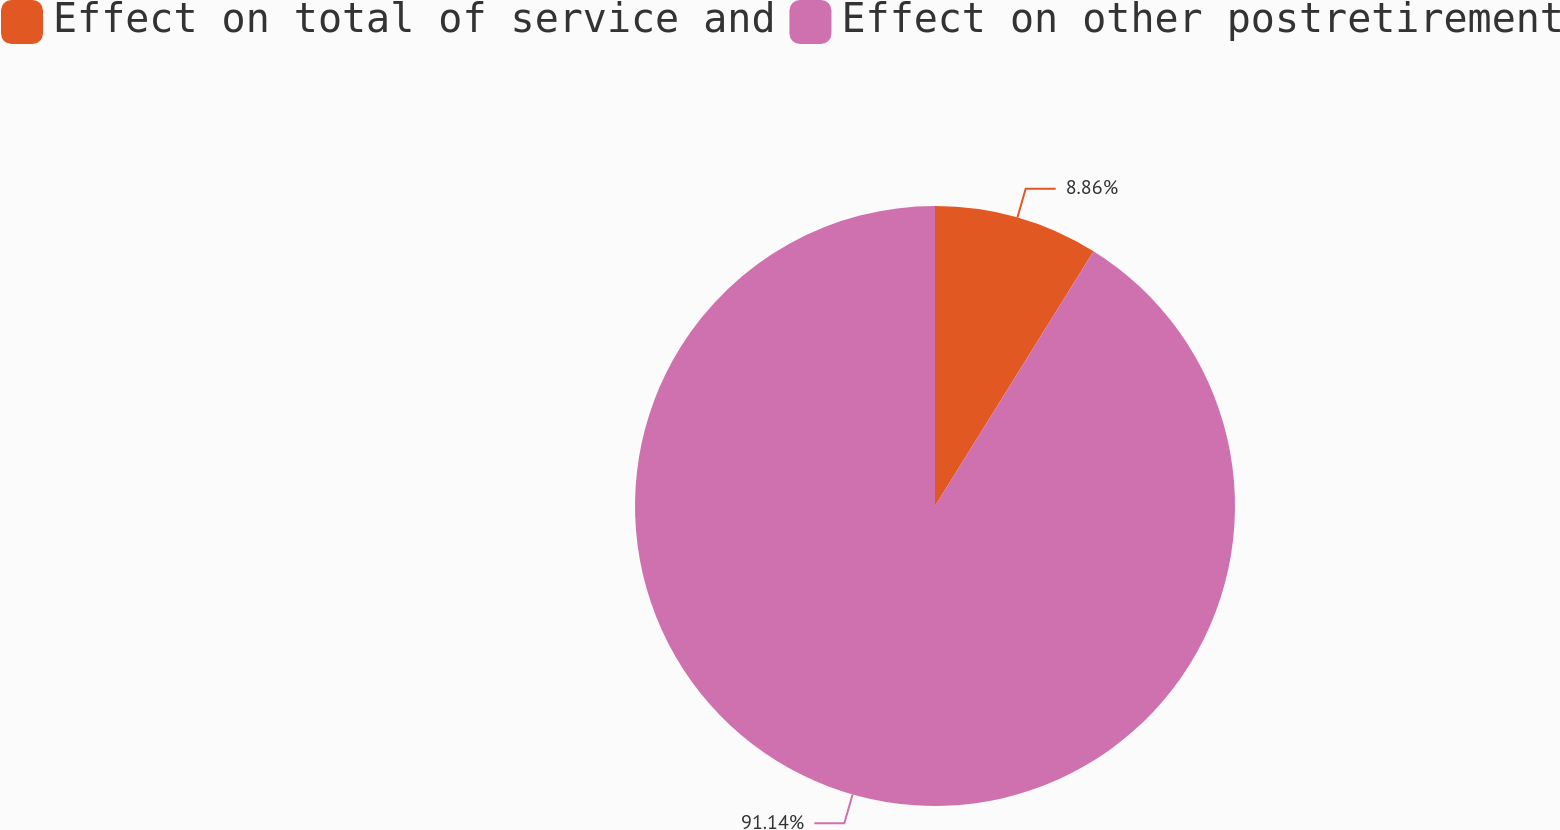Convert chart to OTSL. <chart><loc_0><loc_0><loc_500><loc_500><pie_chart><fcel>Effect on total of service and<fcel>Effect on other postretirement<nl><fcel>8.86%<fcel>91.14%<nl></chart> 